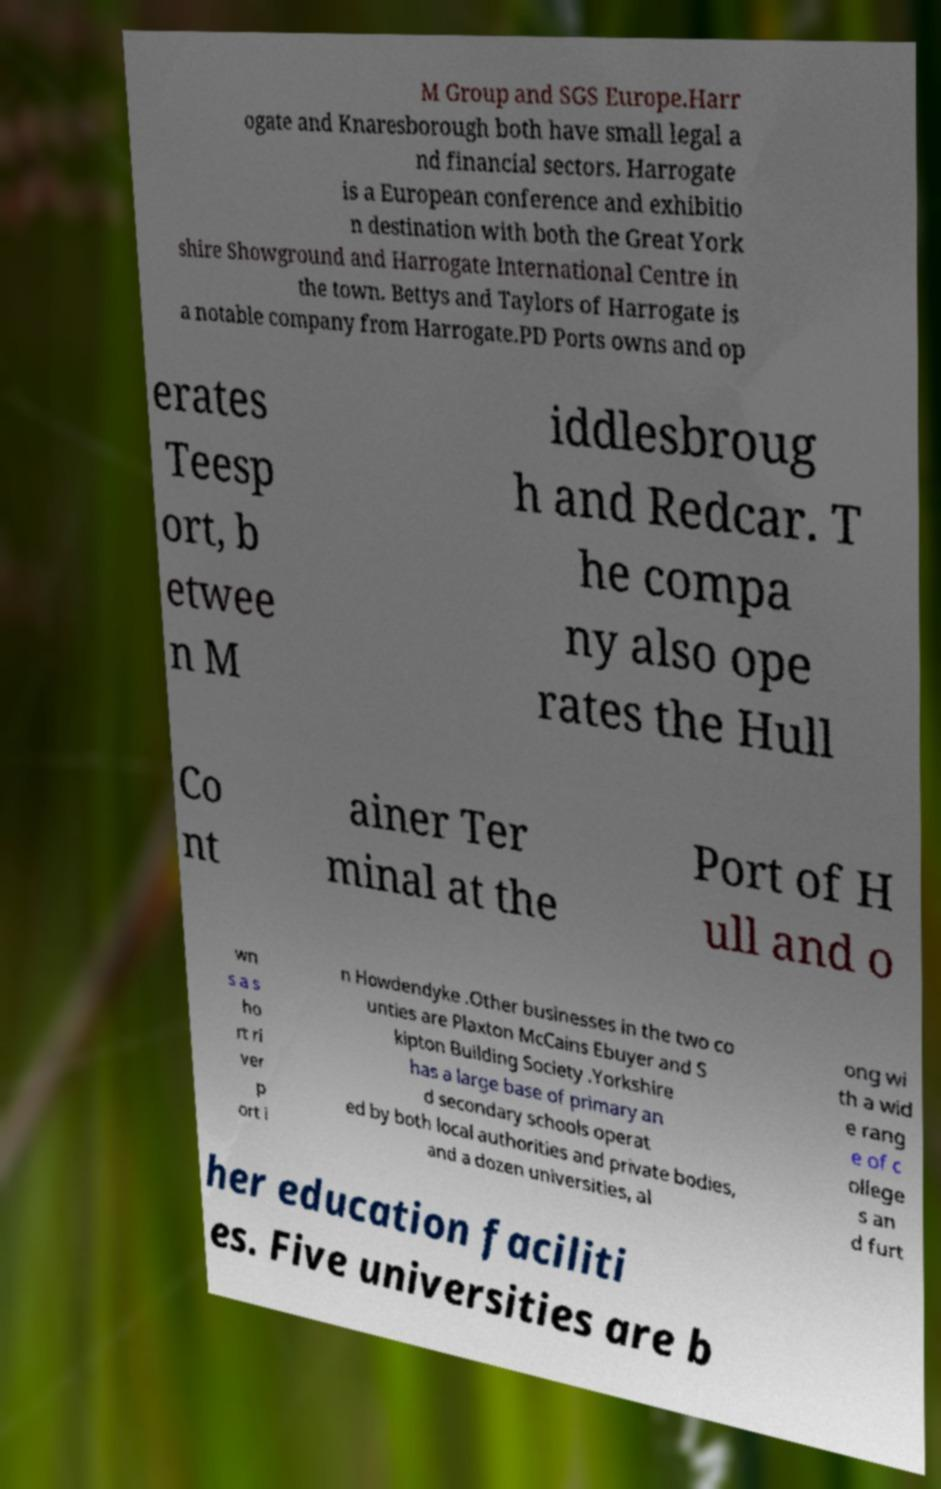Could you extract and type out the text from this image? M Group and SGS Europe.Harr ogate and Knaresborough both have small legal a nd financial sectors. Harrogate is a European conference and exhibitio n destination with both the Great York shire Showground and Harrogate International Centre in the town. Bettys and Taylors of Harrogate is a notable company from Harrogate.PD Ports owns and op erates Teesp ort, b etwee n M iddlesbroug h and Redcar. T he compa ny also ope rates the Hull Co nt ainer Ter minal at the Port of H ull and o wn s a s ho rt ri ver p ort i n Howdendyke .Other businesses in the two co unties are Plaxton McCains Ebuyer and S kipton Building Society .Yorkshire has a large base of primary an d secondary schools operat ed by both local authorities and private bodies, and a dozen universities, al ong wi th a wid e rang e of c ollege s an d furt her education faciliti es. Five universities are b 